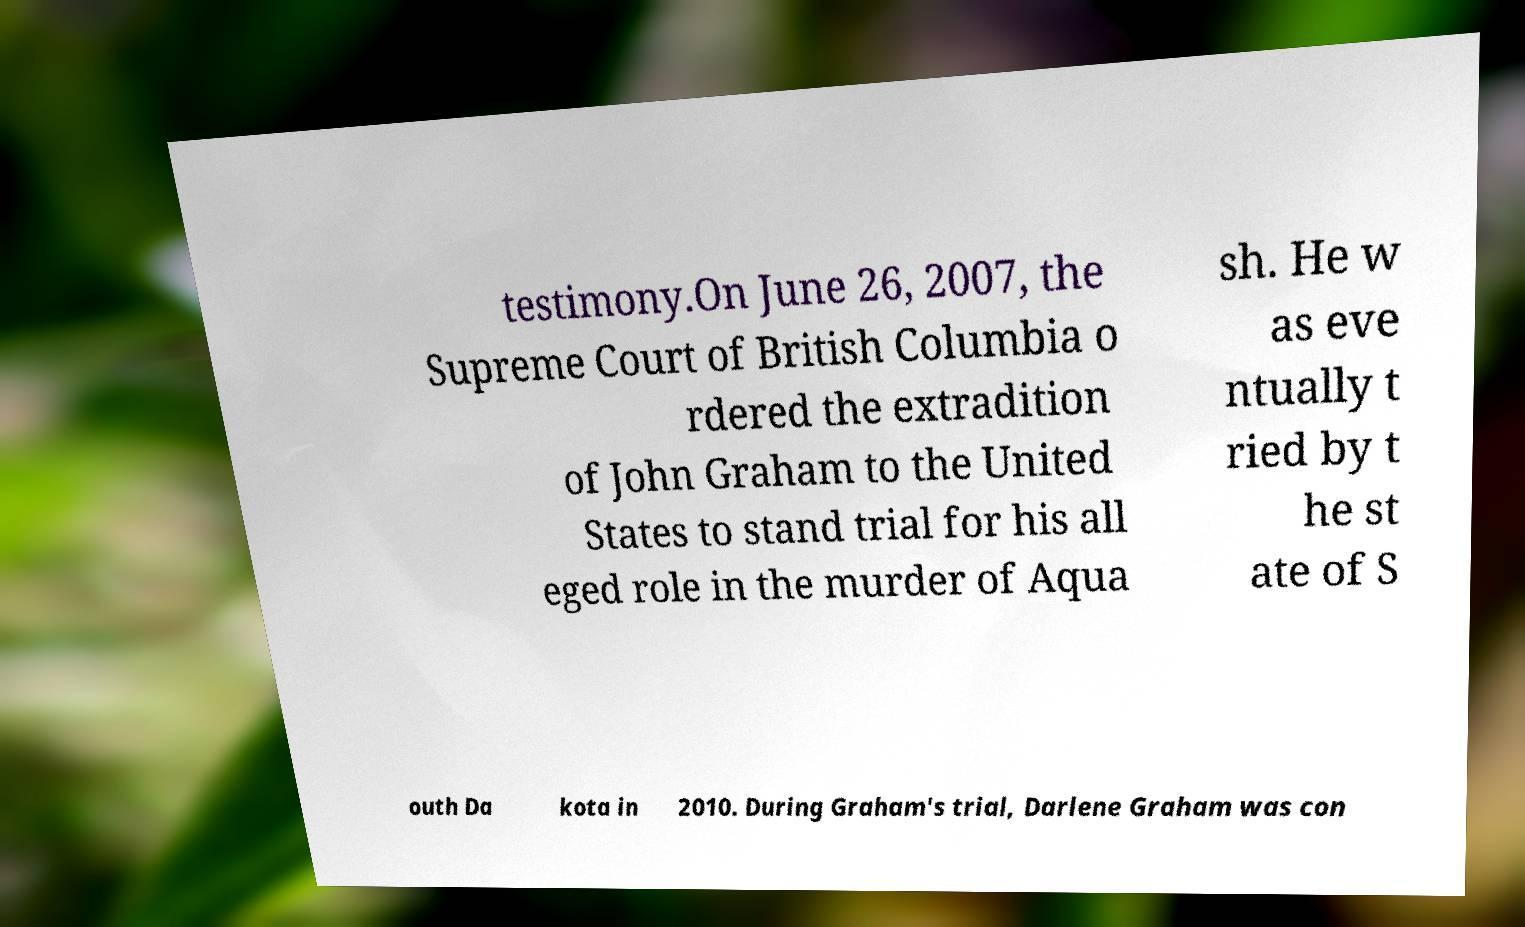Could you assist in decoding the text presented in this image and type it out clearly? testimony.On June 26, 2007, the Supreme Court of British Columbia o rdered the extradition of John Graham to the United States to stand trial for his all eged role in the murder of Aqua sh. He w as eve ntually t ried by t he st ate of S outh Da kota in 2010. During Graham's trial, Darlene Graham was con 